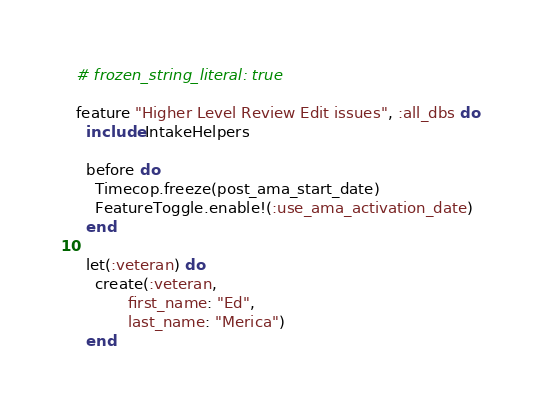Convert code to text. <code><loc_0><loc_0><loc_500><loc_500><_Ruby_># frozen_string_literal: true

feature "Higher Level Review Edit issues", :all_dbs do
  include IntakeHelpers

  before do
    Timecop.freeze(post_ama_start_date)
    FeatureToggle.enable!(:use_ama_activation_date)
  end

  let(:veteran) do
    create(:veteran,
           first_name: "Ed",
           last_name: "Merica")
  end
</code> 